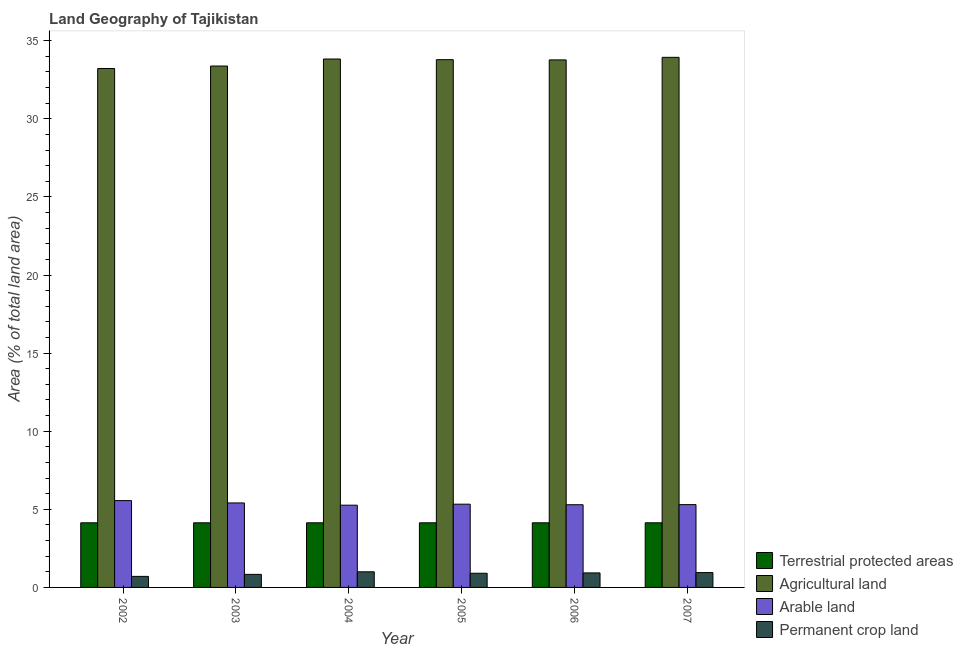How many groups of bars are there?
Make the answer very short. 6. Are the number of bars per tick equal to the number of legend labels?
Your answer should be very brief. Yes. How many bars are there on the 6th tick from the right?
Make the answer very short. 4. What is the label of the 4th group of bars from the left?
Give a very brief answer. 2005. In how many cases, is the number of bars for a given year not equal to the number of legend labels?
Your answer should be very brief. 0. What is the percentage of area under agricultural land in 2005?
Your answer should be very brief. 33.79. Across all years, what is the maximum percentage of area under permanent crop land?
Give a very brief answer. 1. Across all years, what is the minimum percentage of land under terrestrial protection?
Give a very brief answer. 4.14. In which year was the percentage of area under arable land minimum?
Your answer should be very brief. 2004. What is the total percentage of land under terrestrial protection in the graph?
Keep it short and to the point. 24.82. What is the difference between the percentage of land under terrestrial protection in 2002 and that in 2005?
Provide a succinct answer. 0. What is the difference between the percentage of area under agricultural land in 2003 and the percentage of area under permanent crop land in 2002?
Offer a very short reply. 0.16. What is the average percentage of land under terrestrial protection per year?
Provide a short and direct response. 4.14. What is the ratio of the percentage of land under terrestrial protection in 2002 to that in 2003?
Your answer should be very brief. 1. Is the percentage of area under agricultural land in 2002 less than that in 2005?
Provide a succinct answer. Yes. Is the difference between the percentage of land under terrestrial protection in 2002 and 2006 greater than the difference between the percentage of area under permanent crop land in 2002 and 2006?
Make the answer very short. No. What is the difference between the highest and the second highest percentage of area under permanent crop land?
Your answer should be compact. 0.05. What is the difference between the highest and the lowest percentage of area under arable land?
Your response must be concise. 0.29. Is the sum of the percentage of land under terrestrial protection in 2005 and 2006 greater than the maximum percentage of area under agricultural land across all years?
Provide a short and direct response. Yes. Is it the case that in every year, the sum of the percentage of area under permanent crop land and percentage of area under arable land is greater than the sum of percentage of area under agricultural land and percentage of land under terrestrial protection?
Offer a very short reply. No. What does the 3rd bar from the left in 2003 represents?
Offer a terse response. Arable land. What does the 4th bar from the right in 2004 represents?
Provide a succinct answer. Terrestrial protected areas. How many years are there in the graph?
Provide a succinct answer. 6. What is the difference between two consecutive major ticks on the Y-axis?
Provide a succinct answer. 5. What is the title of the graph?
Keep it short and to the point. Land Geography of Tajikistan. What is the label or title of the X-axis?
Offer a terse response. Year. What is the label or title of the Y-axis?
Your answer should be compact. Area (% of total land area). What is the Area (% of total land area) of Terrestrial protected areas in 2002?
Make the answer very short. 4.14. What is the Area (% of total land area) of Agricultural land in 2002?
Provide a short and direct response. 33.22. What is the Area (% of total land area) in Arable land in 2002?
Make the answer very short. 5.56. What is the Area (% of total land area) of Permanent crop land in 2002?
Offer a very short reply. 0.71. What is the Area (% of total land area) of Terrestrial protected areas in 2003?
Provide a succinct answer. 4.14. What is the Area (% of total land area) in Agricultural land in 2003?
Your answer should be compact. 33.38. What is the Area (% of total land area) of Arable land in 2003?
Provide a succinct answer. 5.41. What is the Area (% of total land area) in Permanent crop land in 2003?
Your response must be concise. 0.84. What is the Area (% of total land area) of Terrestrial protected areas in 2004?
Offer a very short reply. 4.14. What is the Area (% of total land area) in Agricultural land in 2004?
Keep it short and to the point. 33.83. What is the Area (% of total land area) of Arable land in 2004?
Provide a succinct answer. 5.27. What is the Area (% of total land area) in Permanent crop land in 2004?
Make the answer very short. 1. What is the Area (% of total land area) in Terrestrial protected areas in 2005?
Ensure brevity in your answer.  4.14. What is the Area (% of total land area) of Agricultural land in 2005?
Offer a terse response. 33.79. What is the Area (% of total land area) in Arable land in 2005?
Offer a terse response. 5.33. What is the Area (% of total land area) of Permanent crop land in 2005?
Your answer should be compact. 0.91. What is the Area (% of total land area) of Terrestrial protected areas in 2006?
Offer a terse response. 4.14. What is the Area (% of total land area) of Agricultural land in 2006?
Your answer should be very brief. 33.77. What is the Area (% of total land area) of Arable land in 2006?
Provide a succinct answer. 5.29. What is the Area (% of total land area) of Permanent crop land in 2006?
Your response must be concise. 0.93. What is the Area (% of total land area) of Terrestrial protected areas in 2007?
Offer a very short reply. 4.14. What is the Area (% of total land area) in Agricultural land in 2007?
Offer a terse response. 33.94. What is the Area (% of total land area) of Arable land in 2007?
Your answer should be compact. 5.3. What is the Area (% of total land area) of Permanent crop land in 2007?
Provide a short and direct response. 0.95. Across all years, what is the maximum Area (% of total land area) in Terrestrial protected areas?
Give a very brief answer. 4.14. Across all years, what is the maximum Area (% of total land area) in Agricultural land?
Make the answer very short. 33.94. Across all years, what is the maximum Area (% of total land area) in Arable land?
Your answer should be compact. 5.56. Across all years, what is the maximum Area (% of total land area) of Permanent crop land?
Provide a short and direct response. 1. Across all years, what is the minimum Area (% of total land area) of Terrestrial protected areas?
Your answer should be compact. 4.14. Across all years, what is the minimum Area (% of total land area) in Agricultural land?
Provide a succinct answer. 33.22. Across all years, what is the minimum Area (% of total land area) of Arable land?
Your answer should be very brief. 5.27. Across all years, what is the minimum Area (% of total land area) of Permanent crop land?
Keep it short and to the point. 0.71. What is the total Area (% of total land area) in Terrestrial protected areas in the graph?
Your answer should be compact. 24.82. What is the total Area (% of total land area) in Agricultural land in the graph?
Ensure brevity in your answer.  201.94. What is the total Area (% of total land area) in Arable land in the graph?
Your response must be concise. 32.16. What is the total Area (% of total land area) in Permanent crop land in the graph?
Your answer should be very brief. 5.33. What is the difference between the Area (% of total land area) in Terrestrial protected areas in 2002 and that in 2003?
Provide a short and direct response. 0. What is the difference between the Area (% of total land area) of Agricultural land in 2002 and that in 2003?
Give a very brief answer. -0.16. What is the difference between the Area (% of total land area) of Arable land in 2002 and that in 2003?
Provide a short and direct response. 0.15. What is the difference between the Area (% of total land area) of Permanent crop land in 2002 and that in 2003?
Offer a terse response. -0.13. What is the difference between the Area (% of total land area) of Agricultural land in 2002 and that in 2004?
Provide a succinct answer. -0.61. What is the difference between the Area (% of total land area) of Arable land in 2002 and that in 2004?
Keep it short and to the point. 0.29. What is the difference between the Area (% of total land area) of Permanent crop land in 2002 and that in 2004?
Offer a very short reply. -0.29. What is the difference between the Area (% of total land area) in Agricultural land in 2002 and that in 2005?
Provide a succinct answer. -0.56. What is the difference between the Area (% of total land area) of Arable land in 2002 and that in 2005?
Give a very brief answer. 0.23. What is the difference between the Area (% of total land area) of Permanent crop land in 2002 and that in 2005?
Make the answer very short. -0.2. What is the difference between the Area (% of total land area) of Agricultural land in 2002 and that in 2006?
Provide a short and direct response. -0.55. What is the difference between the Area (% of total land area) in Arable land in 2002 and that in 2006?
Make the answer very short. 0.26. What is the difference between the Area (% of total land area) in Permanent crop land in 2002 and that in 2006?
Give a very brief answer. -0.22. What is the difference between the Area (% of total land area) in Terrestrial protected areas in 2002 and that in 2007?
Your answer should be very brief. 0. What is the difference between the Area (% of total land area) in Agricultural land in 2002 and that in 2007?
Ensure brevity in your answer.  -0.71. What is the difference between the Area (% of total land area) in Arable land in 2002 and that in 2007?
Ensure brevity in your answer.  0.26. What is the difference between the Area (% of total land area) in Permanent crop land in 2002 and that in 2007?
Give a very brief answer. -0.24. What is the difference between the Area (% of total land area) in Agricultural land in 2003 and that in 2004?
Your answer should be compact. -0.45. What is the difference between the Area (% of total land area) in Arable land in 2003 and that in 2004?
Offer a terse response. 0.14. What is the difference between the Area (% of total land area) in Permanent crop land in 2003 and that in 2004?
Make the answer very short. -0.16. What is the difference between the Area (% of total land area) of Agricultural land in 2003 and that in 2005?
Provide a short and direct response. -0.41. What is the difference between the Area (% of total land area) of Arable land in 2003 and that in 2005?
Make the answer very short. 0.08. What is the difference between the Area (% of total land area) of Permanent crop land in 2003 and that in 2005?
Provide a succinct answer. -0.07. What is the difference between the Area (% of total land area) of Terrestrial protected areas in 2003 and that in 2006?
Offer a very short reply. 0. What is the difference between the Area (% of total land area) in Agricultural land in 2003 and that in 2006?
Provide a short and direct response. -0.39. What is the difference between the Area (% of total land area) of Arable land in 2003 and that in 2006?
Your response must be concise. 0.11. What is the difference between the Area (% of total land area) of Permanent crop land in 2003 and that in 2006?
Your response must be concise. -0.09. What is the difference between the Area (% of total land area) in Terrestrial protected areas in 2003 and that in 2007?
Make the answer very short. 0. What is the difference between the Area (% of total land area) in Agricultural land in 2003 and that in 2007?
Your response must be concise. -0.56. What is the difference between the Area (% of total land area) in Arable land in 2003 and that in 2007?
Your response must be concise. 0.11. What is the difference between the Area (% of total land area) of Permanent crop land in 2003 and that in 2007?
Offer a very short reply. -0.11. What is the difference between the Area (% of total land area) of Terrestrial protected areas in 2004 and that in 2005?
Offer a terse response. 0. What is the difference between the Area (% of total land area) in Agricultural land in 2004 and that in 2005?
Provide a short and direct response. 0.04. What is the difference between the Area (% of total land area) in Arable land in 2004 and that in 2005?
Your answer should be very brief. -0.06. What is the difference between the Area (% of total land area) in Permanent crop land in 2004 and that in 2005?
Ensure brevity in your answer.  0.09. What is the difference between the Area (% of total land area) of Terrestrial protected areas in 2004 and that in 2006?
Give a very brief answer. 0. What is the difference between the Area (% of total land area) in Agricultural land in 2004 and that in 2006?
Your answer should be very brief. 0.06. What is the difference between the Area (% of total land area) in Arable land in 2004 and that in 2006?
Make the answer very short. -0.03. What is the difference between the Area (% of total land area) of Permanent crop land in 2004 and that in 2006?
Provide a short and direct response. 0.07. What is the difference between the Area (% of total land area) in Agricultural land in 2004 and that in 2007?
Ensure brevity in your answer.  -0.11. What is the difference between the Area (% of total land area) in Arable land in 2004 and that in 2007?
Provide a succinct answer. -0.04. What is the difference between the Area (% of total land area) of Agricultural land in 2005 and that in 2006?
Ensure brevity in your answer.  0.01. What is the difference between the Area (% of total land area) in Arable land in 2005 and that in 2006?
Offer a very short reply. 0.04. What is the difference between the Area (% of total land area) in Permanent crop land in 2005 and that in 2006?
Provide a succinct answer. -0.02. What is the difference between the Area (% of total land area) in Terrestrial protected areas in 2005 and that in 2007?
Provide a short and direct response. 0. What is the difference between the Area (% of total land area) in Arable land in 2005 and that in 2007?
Offer a very short reply. 0.03. What is the difference between the Area (% of total land area) of Permanent crop land in 2005 and that in 2007?
Offer a terse response. -0.04. What is the difference between the Area (% of total land area) of Agricultural land in 2006 and that in 2007?
Keep it short and to the point. -0.16. What is the difference between the Area (% of total land area) of Arable land in 2006 and that in 2007?
Give a very brief answer. -0.01. What is the difference between the Area (% of total land area) of Permanent crop land in 2006 and that in 2007?
Your response must be concise. -0.02. What is the difference between the Area (% of total land area) of Terrestrial protected areas in 2002 and the Area (% of total land area) of Agricultural land in 2003?
Offer a terse response. -29.24. What is the difference between the Area (% of total land area) in Terrestrial protected areas in 2002 and the Area (% of total land area) in Arable land in 2003?
Your answer should be very brief. -1.27. What is the difference between the Area (% of total land area) in Terrestrial protected areas in 2002 and the Area (% of total land area) in Permanent crop land in 2003?
Offer a terse response. 3.3. What is the difference between the Area (% of total land area) of Agricultural land in 2002 and the Area (% of total land area) of Arable land in 2003?
Give a very brief answer. 27.82. What is the difference between the Area (% of total land area) of Agricultural land in 2002 and the Area (% of total land area) of Permanent crop land in 2003?
Offer a very short reply. 32.39. What is the difference between the Area (% of total land area) in Arable land in 2002 and the Area (% of total land area) in Permanent crop land in 2003?
Your answer should be compact. 4.72. What is the difference between the Area (% of total land area) of Terrestrial protected areas in 2002 and the Area (% of total land area) of Agricultural land in 2004?
Offer a terse response. -29.69. What is the difference between the Area (% of total land area) in Terrestrial protected areas in 2002 and the Area (% of total land area) in Arable land in 2004?
Your answer should be compact. -1.13. What is the difference between the Area (% of total land area) in Terrestrial protected areas in 2002 and the Area (% of total land area) in Permanent crop land in 2004?
Ensure brevity in your answer.  3.14. What is the difference between the Area (% of total land area) in Agricultural land in 2002 and the Area (% of total land area) in Arable land in 2004?
Keep it short and to the point. 27.96. What is the difference between the Area (% of total land area) of Agricultural land in 2002 and the Area (% of total land area) of Permanent crop land in 2004?
Your answer should be very brief. 32.22. What is the difference between the Area (% of total land area) in Arable land in 2002 and the Area (% of total land area) in Permanent crop land in 2004?
Your response must be concise. 4.56. What is the difference between the Area (% of total land area) of Terrestrial protected areas in 2002 and the Area (% of total land area) of Agricultural land in 2005?
Your response must be concise. -29.65. What is the difference between the Area (% of total land area) in Terrestrial protected areas in 2002 and the Area (% of total land area) in Arable land in 2005?
Your answer should be compact. -1.19. What is the difference between the Area (% of total land area) in Terrestrial protected areas in 2002 and the Area (% of total land area) in Permanent crop land in 2005?
Provide a short and direct response. 3.23. What is the difference between the Area (% of total land area) in Agricultural land in 2002 and the Area (% of total land area) in Arable land in 2005?
Offer a terse response. 27.89. What is the difference between the Area (% of total land area) of Agricultural land in 2002 and the Area (% of total land area) of Permanent crop land in 2005?
Provide a succinct answer. 32.32. What is the difference between the Area (% of total land area) of Arable land in 2002 and the Area (% of total land area) of Permanent crop land in 2005?
Provide a short and direct response. 4.65. What is the difference between the Area (% of total land area) in Terrestrial protected areas in 2002 and the Area (% of total land area) in Agricultural land in 2006?
Offer a terse response. -29.64. What is the difference between the Area (% of total land area) in Terrestrial protected areas in 2002 and the Area (% of total land area) in Arable land in 2006?
Make the answer very short. -1.16. What is the difference between the Area (% of total land area) in Terrestrial protected areas in 2002 and the Area (% of total land area) in Permanent crop land in 2006?
Offer a terse response. 3.21. What is the difference between the Area (% of total land area) of Agricultural land in 2002 and the Area (% of total land area) of Arable land in 2006?
Your answer should be compact. 27.93. What is the difference between the Area (% of total land area) of Agricultural land in 2002 and the Area (% of total land area) of Permanent crop land in 2006?
Make the answer very short. 32.29. What is the difference between the Area (% of total land area) of Arable land in 2002 and the Area (% of total land area) of Permanent crop land in 2006?
Make the answer very short. 4.63. What is the difference between the Area (% of total land area) of Terrestrial protected areas in 2002 and the Area (% of total land area) of Agricultural land in 2007?
Provide a succinct answer. -29.8. What is the difference between the Area (% of total land area) of Terrestrial protected areas in 2002 and the Area (% of total land area) of Arable land in 2007?
Give a very brief answer. -1.16. What is the difference between the Area (% of total land area) in Terrestrial protected areas in 2002 and the Area (% of total land area) in Permanent crop land in 2007?
Provide a succinct answer. 3.19. What is the difference between the Area (% of total land area) in Agricultural land in 2002 and the Area (% of total land area) in Arable land in 2007?
Offer a very short reply. 27.92. What is the difference between the Area (% of total land area) of Agricultural land in 2002 and the Area (% of total land area) of Permanent crop land in 2007?
Your answer should be compact. 32.27. What is the difference between the Area (% of total land area) in Arable land in 2002 and the Area (% of total land area) in Permanent crop land in 2007?
Your answer should be compact. 4.61. What is the difference between the Area (% of total land area) in Terrestrial protected areas in 2003 and the Area (% of total land area) in Agricultural land in 2004?
Provide a short and direct response. -29.69. What is the difference between the Area (% of total land area) in Terrestrial protected areas in 2003 and the Area (% of total land area) in Arable land in 2004?
Provide a succinct answer. -1.13. What is the difference between the Area (% of total land area) in Terrestrial protected areas in 2003 and the Area (% of total land area) in Permanent crop land in 2004?
Your answer should be compact. 3.14. What is the difference between the Area (% of total land area) of Agricultural land in 2003 and the Area (% of total land area) of Arable land in 2004?
Provide a succinct answer. 28.12. What is the difference between the Area (% of total land area) of Agricultural land in 2003 and the Area (% of total land area) of Permanent crop land in 2004?
Keep it short and to the point. 32.38. What is the difference between the Area (% of total land area) in Arable land in 2003 and the Area (% of total land area) in Permanent crop land in 2004?
Ensure brevity in your answer.  4.41. What is the difference between the Area (% of total land area) in Terrestrial protected areas in 2003 and the Area (% of total land area) in Agricultural land in 2005?
Provide a short and direct response. -29.65. What is the difference between the Area (% of total land area) in Terrestrial protected areas in 2003 and the Area (% of total land area) in Arable land in 2005?
Offer a very short reply. -1.19. What is the difference between the Area (% of total land area) of Terrestrial protected areas in 2003 and the Area (% of total land area) of Permanent crop land in 2005?
Keep it short and to the point. 3.23. What is the difference between the Area (% of total land area) of Agricultural land in 2003 and the Area (% of total land area) of Arable land in 2005?
Give a very brief answer. 28.05. What is the difference between the Area (% of total land area) of Agricultural land in 2003 and the Area (% of total land area) of Permanent crop land in 2005?
Keep it short and to the point. 32.47. What is the difference between the Area (% of total land area) in Arable land in 2003 and the Area (% of total land area) in Permanent crop land in 2005?
Offer a very short reply. 4.5. What is the difference between the Area (% of total land area) in Terrestrial protected areas in 2003 and the Area (% of total land area) in Agricultural land in 2006?
Keep it short and to the point. -29.64. What is the difference between the Area (% of total land area) of Terrestrial protected areas in 2003 and the Area (% of total land area) of Arable land in 2006?
Your response must be concise. -1.16. What is the difference between the Area (% of total land area) of Terrestrial protected areas in 2003 and the Area (% of total land area) of Permanent crop land in 2006?
Your response must be concise. 3.21. What is the difference between the Area (% of total land area) of Agricultural land in 2003 and the Area (% of total land area) of Arable land in 2006?
Provide a short and direct response. 28.09. What is the difference between the Area (% of total land area) of Agricultural land in 2003 and the Area (% of total land area) of Permanent crop land in 2006?
Provide a short and direct response. 32.45. What is the difference between the Area (% of total land area) in Arable land in 2003 and the Area (% of total land area) in Permanent crop land in 2006?
Your answer should be very brief. 4.48. What is the difference between the Area (% of total land area) in Terrestrial protected areas in 2003 and the Area (% of total land area) in Agricultural land in 2007?
Your answer should be compact. -29.8. What is the difference between the Area (% of total land area) in Terrestrial protected areas in 2003 and the Area (% of total land area) in Arable land in 2007?
Provide a short and direct response. -1.16. What is the difference between the Area (% of total land area) in Terrestrial protected areas in 2003 and the Area (% of total land area) in Permanent crop land in 2007?
Your answer should be compact. 3.19. What is the difference between the Area (% of total land area) of Agricultural land in 2003 and the Area (% of total land area) of Arable land in 2007?
Provide a short and direct response. 28.08. What is the difference between the Area (% of total land area) of Agricultural land in 2003 and the Area (% of total land area) of Permanent crop land in 2007?
Your answer should be compact. 32.43. What is the difference between the Area (% of total land area) in Arable land in 2003 and the Area (% of total land area) in Permanent crop land in 2007?
Offer a very short reply. 4.46. What is the difference between the Area (% of total land area) in Terrestrial protected areas in 2004 and the Area (% of total land area) in Agricultural land in 2005?
Ensure brevity in your answer.  -29.65. What is the difference between the Area (% of total land area) in Terrestrial protected areas in 2004 and the Area (% of total land area) in Arable land in 2005?
Provide a succinct answer. -1.19. What is the difference between the Area (% of total land area) of Terrestrial protected areas in 2004 and the Area (% of total land area) of Permanent crop land in 2005?
Provide a short and direct response. 3.23. What is the difference between the Area (% of total land area) in Agricultural land in 2004 and the Area (% of total land area) in Arable land in 2005?
Provide a short and direct response. 28.5. What is the difference between the Area (% of total land area) in Agricultural land in 2004 and the Area (% of total land area) in Permanent crop land in 2005?
Offer a very short reply. 32.92. What is the difference between the Area (% of total land area) of Arable land in 2004 and the Area (% of total land area) of Permanent crop land in 2005?
Your response must be concise. 4.36. What is the difference between the Area (% of total land area) in Terrestrial protected areas in 2004 and the Area (% of total land area) in Agricultural land in 2006?
Keep it short and to the point. -29.64. What is the difference between the Area (% of total land area) of Terrestrial protected areas in 2004 and the Area (% of total land area) of Arable land in 2006?
Make the answer very short. -1.16. What is the difference between the Area (% of total land area) of Terrestrial protected areas in 2004 and the Area (% of total land area) of Permanent crop land in 2006?
Your answer should be compact. 3.21. What is the difference between the Area (% of total land area) in Agricultural land in 2004 and the Area (% of total land area) in Arable land in 2006?
Offer a terse response. 28.54. What is the difference between the Area (% of total land area) of Agricultural land in 2004 and the Area (% of total land area) of Permanent crop land in 2006?
Provide a short and direct response. 32.9. What is the difference between the Area (% of total land area) of Arable land in 2004 and the Area (% of total land area) of Permanent crop land in 2006?
Offer a very short reply. 4.34. What is the difference between the Area (% of total land area) of Terrestrial protected areas in 2004 and the Area (% of total land area) of Agricultural land in 2007?
Provide a short and direct response. -29.8. What is the difference between the Area (% of total land area) of Terrestrial protected areas in 2004 and the Area (% of total land area) of Arable land in 2007?
Your response must be concise. -1.16. What is the difference between the Area (% of total land area) in Terrestrial protected areas in 2004 and the Area (% of total land area) in Permanent crop land in 2007?
Offer a very short reply. 3.19. What is the difference between the Area (% of total land area) of Agricultural land in 2004 and the Area (% of total land area) of Arable land in 2007?
Offer a terse response. 28.53. What is the difference between the Area (% of total land area) in Agricultural land in 2004 and the Area (% of total land area) in Permanent crop land in 2007?
Provide a short and direct response. 32.88. What is the difference between the Area (% of total land area) of Arable land in 2004 and the Area (% of total land area) of Permanent crop land in 2007?
Your answer should be very brief. 4.32. What is the difference between the Area (% of total land area) of Terrestrial protected areas in 2005 and the Area (% of total land area) of Agricultural land in 2006?
Offer a very short reply. -29.64. What is the difference between the Area (% of total land area) in Terrestrial protected areas in 2005 and the Area (% of total land area) in Arable land in 2006?
Make the answer very short. -1.16. What is the difference between the Area (% of total land area) of Terrestrial protected areas in 2005 and the Area (% of total land area) of Permanent crop land in 2006?
Your answer should be compact. 3.21. What is the difference between the Area (% of total land area) of Agricultural land in 2005 and the Area (% of total land area) of Arable land in 2006?
Your response must be concise. 28.49. What is the difference between the Area (% of total land area) in Agricultural land in 2005 and the Area (% of total land area) in Permanent crop land in 2006?
Your answer should be very brief. 32.86. What is the difference between the Area (% of total land area) of Arable land in 2005 and the Area (% of total land area) of Permanent crop land in 2006?
Provide a short and direct response. 4.4. What is the difference between the Area (% of total land area) of Terrestrial protected areas in 2005 and the Area (% of total land area) of Agricultural land in 2007?
Offer a terse response. -29.8. What is the difference between the Area (% of total land area) of Terrestrial protected areas in 2005 and the Area (% of total land area) of Arable land in 2007?
Keep it short and to the point. -1.16. What is the difference between the Area (% of total land area) in Terrestrial protected areas in 2005 and the Area (% of total land area) in Permanent crop land in 2007?
Make the answer very short. 3.19. What is the difference between the Area (% of total land area) in Agricultural land in 2005 and the Area (% of total land area) in Arable land in 2007?
Give a very brief answer. 28.49. What is the difference between the Area (% of total land area) in Agricultural land in 2005 and the Area (% of total land area) in Permanent crop land in 2007?
Keep it short and to the point. 32.84. What is the difference between the Area (% of total land area) in Arable land in 2005 and the Area (% of total land area) in Permanent crop land in 2007?
Offer a very short reply. 4.38. What is the difference between the Area (% of total land area) of Terrestrial protected areas in 2006 and the Area (% of total land area) of Agricultural land in 2007?
Give a very brief answer. -29.8. What is the difference between the Area (% of total land area) of Terrestrial protected areas in 2006 and the Area (% of total land area) of Arable land in 2007?
Your answer should be compact. -1.16. What is the difference between the Area (% of total land area) in Terrestrial protected areas in 2006 and the Area (% of total land area) in Permanent crop land in 2007?
Provide a short and direct response. 3.19. What is the difference between the Area (% of total land area) of Agricultural land in 2006 and the Area (% of total land area) of Arable land in 2007?
Offer a terse response. 28.47. What is the difference between the Area (% of total land area) of Agricultural land in 2006 and the Area (% of total land area) of Permanent crop land in 2007?
Your answer should be very brief. 32.82. What is the difference between the Area (% of total land area) in Arable land in 2006 and the Area (% of total land area) in Permanent crop land in 2007?
Your response must be concise. 4.34. What is the average Area (% of total land area) in Terrestrial protected areas per year?
Make the answer very short. 4.14. What is the average Area (% of total land area) of Agricultural land per year?
Keep it short and to the point. 33.66. What is the average Area (% of total land area) in Arable land per year?
Your response must be concise. 5.36. What is the average Area (% of total land area) in Permanent crop land per year?
Your answer should be compact. 0.89. In the year 2002, what is the difference between the Area (% of total land area) of Terrestrial protected areas and Area (% of total land area) of Agricultural land?
Offer a very short reply. -29.09. In the year 2002, what is the difference between the Area (% of total land area) in Terrestrial protected areas and Area (% of total land area) in Arable land?
Provide a short and direct response. -1.42. In the year 2002, what is the difference between the Area (% of total land area) of Terrestrial protected areas and Area (% of total land area) of Permanent crop land?
Your response must be concise. 3.43. In the year 2002, what is the difference between the Area (% of total land area) of Agricultural land and Area (% of total land area) of Arable land?
Your answer should be compact. 27.66. In the year 2002, what is the difference between the Area (% of total land area) of Agricultural land and Area (% of total land area) of Permanent crop land?
Make the answer very short. 32.52. In the year 2002, what is the difference between the Area (% of total land area) in Arable land and Area (% of total land area) in Permanent crop land?
Your response must be concise. 4.85. In the year 2003, what is the difference between the Area (% of total land area) of Terrestrial protected areas and Area (% of total land area) of Agricultural land?
Keep it short and to the point. -29.24. In the year 2003, what is the difference between the Area (% of total land area) in Terrestrial protected areas and Area (% of total land area) in Arable land?
Make the answer very short. -1.27. In the year 2003, what is the difference between the Area (% of total land area) of Terrestrial protected areas and Area (% of total land area) of Permanent crop land?
Offer a very short reply. 3.3. In the year 2003, what is the difference between the Area (% of total land area) of Agricultural land and Area (% of total land area) of Arable land?
Your answer should be compact. 27.97. In the year 2003, what is the difference between the Area (% of total land area) of Agricultural land and Area (% of total land area) of Permanent crop land?
Offer a very short reply. 32.55. In the year 2003, what is the difference between the Area (% of total land area) of Arable land and Area (% of total land area) of Permanent crop land?
Make the answer very short. 4.57. In the year 2004, what is the difference between the Area (% of total land area) of Terrestrial protected areas and Area (% of total land area) of Agricultural land?
Make the answer very short. -29.69. In the year 2004, what is the difference between the Area (% of total land area) of Terrestrial protected areas and Area (% of total land area) of Arable land?
Keep it short and to the point. -1.13. In the year 2004, what is the difference between the Area (% of total land area) in Terrestrial protected areas and Area (% of total land area) in Permanent crop land?
Your response must be concise. 3.14. In the year 2004, what is the difference between the Area (% of total land area) in Agricultural land and Area (% of total land area) in Arable land?
Offer a very short reply. 28.57. In the year 2004, what is the difference between the Area (% of total land area) in Agricultural land and Area (% of total land area) in Permanent crop land?
Provide a succinct answer. 32.83. In the year 2004, what is the difference between the Area (% of total land area) of Arable land and Area (% of total land area) of Permanent crop land?
Make the answer very short. 4.27. In the year 2005, what is the difference between the Area (% of total land area) of Terrestrial protected areas and Area (% of total land area) of Agricultural land?
Make the answer very short. -29.65. In the year 2005, what is the difference between the Area (% of total land area) in Terrestrial protected areas and Area (% of total land area) in Arable land?
Keep it short and to the point. -1.19. In the year 2005, what is the difference between the Area (% of total land area) in Terrestrial protected areas and Area (% of total land area) in Permanent crop land?
Provide a succinct answer. 3.23. In the year 2005, what is the difference between the Area (% of total land area) in Agricultural land and Area (% of total land area) in Arable land?
Your response must be concise. 28.46. In the year 2005, what is the difference between the Area (% of total land area) of Agricultural land and Area (% of total land area) of Permanent crop land?
Your answer should be compact. 32.88. In the year 2005, what is the difference between the Area (% of total land area) in Arable land and Area (% of total land area) in Permanent crop land?
Give a very brief answer. 4.42. In the year 2006, what is the difference between the Area (% of total land area) of Terrestrial protected areas and Area (% of total land area) of Agricultural land?
Offer a very short reply. -29.64. In the year 2006, what is the difference between the Area (% of total land area) in Terrestrial protected areas and Area (% of total land area) in Arable land?
Provide a succinct answer. -1.16. In the year 2006, what is the difference between the Area (% of total land area) of Terrestrial protected areas and Area (% of total land area) of Permanent crop land?
Provide a succinct answer. 3.21. In the year 2006, what is the difference between the Area (% of total land area) of Agricultural land and Area (% of total land area) of Arable land?
Provide a short and direct response. 28.48. In the year 2006, what is the difference between the Area (% of total land area) of Agricultural land and Area (% of total land area) of Permanent crop land?
Offer a terse response. 32.85. In the year 2006, what is the difference between the Area (% of total land area) in Arable land and Area (% of total land area) in Permanent crop land?
Give a very brief answer. 4.37. In the year 2007, what is the difference between the Area (% of total land area) of Terrestrial protected areas and Area (% of total land area) of Agricultural land?
Your answer should be very brief. -29.8. In the year 2007, what is the difference between the Area (% of total land area) of Terrestrial protected areas and Area (% of total land area) of Arable land?
Give a very brief answer. -1.16. In the year 2007, what is the difference between the Area (% of total land area) in Terrestrial protected areas and Area (% of total land area) in Permanent crop land?
Make the answer very short. 3.19. In the year 2007, what is the difference between the Area (% of total land area) in Agricultural land and Area (% of total land area) in Arable land?
Offer a terse response. 28.64. In the year 2007, what is the difference between the Area (% of total land area) in Agricultural land and Area (% of total land area) in Permanent crop land?
Make the answer very short. 32.99. In the year 2007, what is the difference between the Area (% of total land area) in Arable land and Area (% of total land area) in Permanent crop land?
Provide a succinct answer. 4.35. What is the ratio of the Area (% of total land area) in Terrestrial protected areas in 2002 to that in 2003?
Your response must be concise. 1. What is the ratio of the Area (% of total land area) in Arable land in 2002 to that in 2003?
Keep it short and to the point. 1.03. What is the ratio of the Area (% of total land area) of Permanent crop land in 2002 to that in 2003?
Give a very brief answer. 0.85. What is the ratio of the Area (% of total land area) of Arable land in 2002 to that in 2004?
Your answer should be compact. 1.06. What is the ratio of the Area (% of total land area) in Permanent crop land in 2002 to that in 2004?
Give a very brief answer. 0.71. What is the ratio of the Area (% of total land area) in Agricultural land in 2002 to that in 2005?
Ensure brevity in your answer.  0.98. What is the ratio of the Area (% of total land area) in Arable land in 2002 to that in 2005?
Offer a terse response. 1.04. What is the ratio of the Area (% of total land area) in Permanent crop land in 2002 to that in 2005?
Give a very brief answer. 0.78. What is the ratio of the Area (% of total land area) in Terrestrial protected areas in 2002 to that in 2006?
Make the answer very short. 1. What is the ratio of the Area (% of total land area) of Agricultural land in 2002 to that in 2006?
Your answer should be compact. 0.98. What is the ratio of the Area (% of total land area) in Arable land in 2002 to that in 2006?
Your answer should be very brief. 1.05. What is the ratio of the Area (% of total land area) of Permanent crop land in 2002 to that in 2006?
Your response must be concise. 0.76. What is the ratio of the Area (% of total land area) of Agricultural land in 2002 to that in 2007?
Your answer should be compact. 0.98. What is the ratio of the Area (% of total land area) of Arable land in 2002 to that in 2007?
Your answer should be compact. 1.05. What is the ratio of the Area (% of total land area) of Permanent crop land in 2002 to that in 2007?
Your response must be concise. 0.74. What is the ratio of the Area (% of total land area) in Agricultural land in 2003 to that in 2004?
Offer a terse response. 0.99. What is the ratio of the Area (% of total land area) in Arable land in 2003 to that in 2004?
Your response must be concise. 1.03. What is the ratio of the Area (% of total land area) of Permanent crop land in 2003 to that in 2004?
Your answer should be compact. 0.84. What is the ratio of the Area (% of total land area) of Terrestrial protected areas in 2003 to that in 2005?
Keep it short and to the point. 1. What is the ratio of the Area (% of total land area) in Agricultural land in 2003 to that in 2005?
Make the answer very short. 0.99. What is the ratio of the Area (% of total land area) of Arable land in 2003 to that in 2005?
Keep it short and to the point. 1.01. What is the ratio of the Area (% of total land area) in Permanent crop land in 2003 to that in 2005?
Offer a very short reply. 0.92. What is the ratio of the Area (% of total land area) of Agricultural land in 2003 to that in 2006?
Offer a terse response. 0.99. What is the ratio of the Area (% of total land area) in Arable land in 2003 to that in 2006?
Your answer should be very brief. 1.02. What is the ratio of the Area (% of total land area) in Terrestrial protected areas in 2003 to that in 2007?
Keep it short and to the point. 1. What is the ratio of the Area (% of total land area) of Agricultural land in 2003 to that in 2007?
Your answer should be very brief. 0.98. What is the ratio of the Area (% of total land area) in Arable land in 2003 to that in 2007?
Provide a succinct answer. 1.02. What is the ratio of the Area (% of total land area) of Permanent crop land in 2003 to that in 2007?
Offer a very short reply. 0.88. What is the ratio of the Area (% of total land area) of Agricultural land in 2004 to that in 2005?
Keep it short and to the point. 1. What is the ratio of the Area (% of total land area) of Arable land in 2004 to that in 2005?
Provide a short and direct response. 0.99. What is the ratio of the Area (% of total land area) of Permanent crop land in 2004 to that in 2005?
Offer a terse response. 1.1. What is the ratio of the Area (% of total land area) of Permanent crop land in 2004 to that in 2006?
Offer a terse response. 1.08. What is the ratio of the Area (% of total land area) in Agricultural land in 2004 to that in 2007?
Your answer should be very brief. 1. What is the ratio of the Area (% of total land area) of Permanent crop land in 2004 to that in 2007?
Give a very brief answer. 1.05. What is the ratio of the Area (% of total land area) of Terrestrial protected areas in 2005 to that in 2006?
Offer a very short reply. 1. What is the ratio of the Area (% of total land area) of Permanent crop land in 2005 to that in 2006?
Your response must be concise. 0.98. What is the ratio of the Area (% of total land area) of Arable land in 2005 to that in 2007?
Ensure brevity in your answer.  1.01. What is the ratio of the Area (% of total land area) in Permanent crop land in 2005 to that in 2007?
Offer a terse response. 0.95. What is the ratio of the Area (% of total land area) in Agricultural land in 2006 to that in 2007?
Your answer should be compact. 1. What is the ratio of the Area (% of total land area) in Arable land in 2006 to that in 2007?
Keep it short and to the point. 1. What is the ratio of the Area (% of total land area) in Permanent crop land in 2006 to that in 2007?
Ensure brevity in your answer.  0.98. What is the difference between the highest and the second highest Area (% of total land area) in Terrestrial protected areas?
Provide a short and direct response. 0. What is the difference between the highest and the second highest Area (% of total land area) of Agricultural land?
Provide a short and direct response. 0.11. What is the difference between the highest and the second highest Area (% of total land area) in Arable land?
Make the answer very short. 0.15. What is the difference between the highest and the lowest Area (% of total land area) of Agricultural land?
Keep it short and to the point. 0.71. What is the difference between the highest and the lowest Area (% of total land area) in Arable land?
Give a very brief answer. 0.29. What is the difference between the highest and the lowest Area (% of total land area) in Permanent crop land?
Keep it short and to the point. 0.29. 